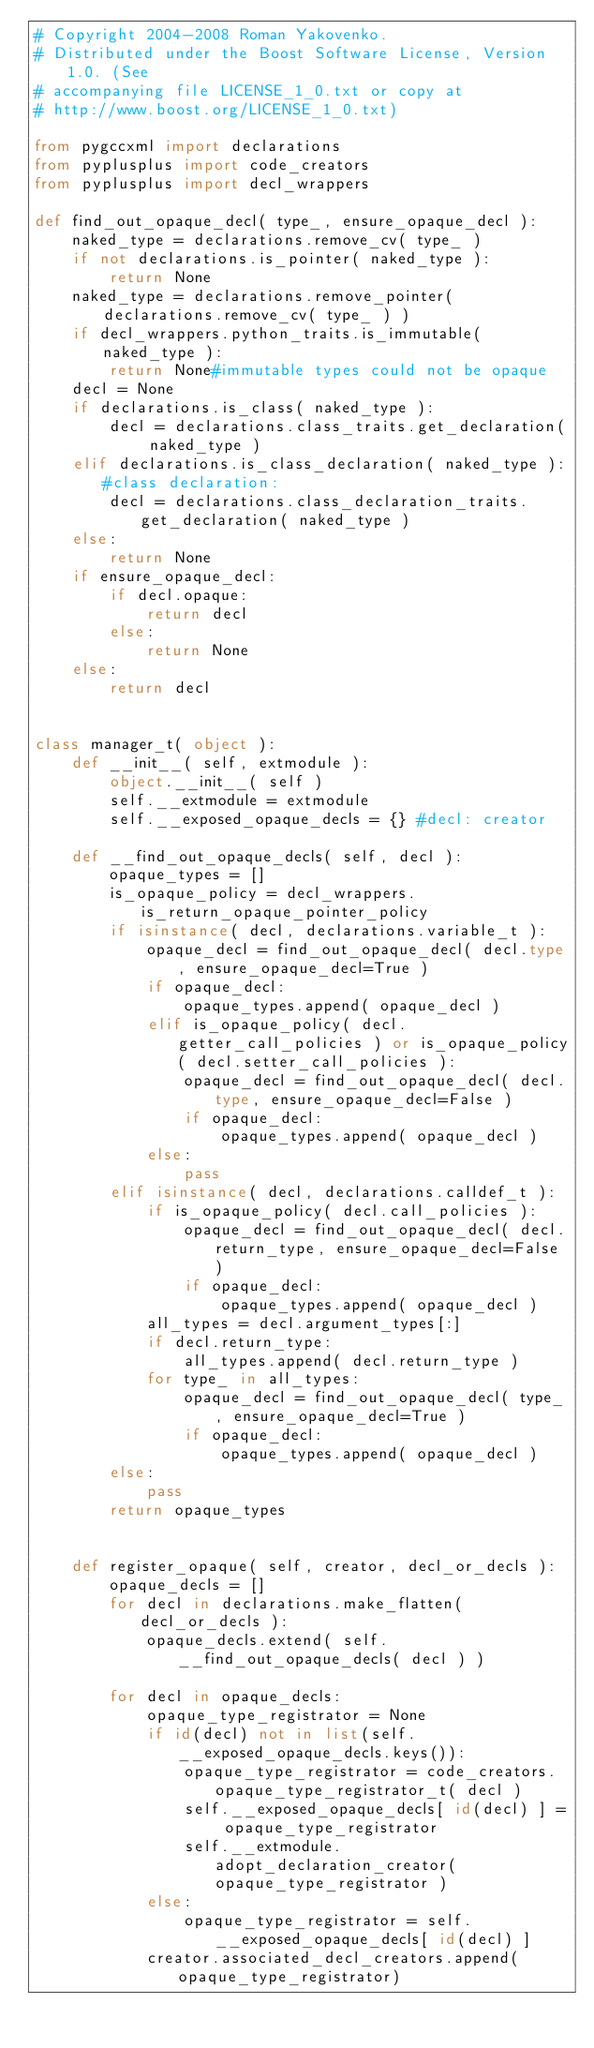Convert code to text. <code><loc_0><loc_0><loc_500><loc_500><_Python_># Copyright 2004-2008 Roman Yakovenko.
# Distributed under the Boost Software License, Version 1.0. (See
# accompanying file LICENSE_1_0.txt or copy at
# http://www.boost.org/LICENSE_1_0.txt)

from pygccxml import declarations
from pyplusplus import code_creators
from pyplusplus import decl_wrappers

def find_out_opaque_decl( type_, ensure_opaque_decl ):
    naked_type = declarations.remove_cv( type_ )
    if not declarations.is_pointer( naked_type ):
        return None
    naked_type = declarations.remove_pointer( declarations.remove_cv( type_ ) )
    if decl_wrappers.python_traits.is_immutable( naked_type ):
        return None#immutable types could not be opaque
    decl = None
    if declarations.is_class( naked_type ):
        decl = declarations.class_traits.get_declaration( naked_type )
    elif declarations.is_class_declaration( naked_type ):#class declaration:
        decl = declarations.class_declaration_traits.get_declaration( naked_type )
    else:
        return None
    if ensure_opaque_decl:
        if decl.opaque:
            return decl
        else:
            return None
    else:
        return decl


class manager_t( object ):
    def __init__( self, extmodule ):
        object.__init__( self )
        self.__extmodule = extmodule
        self.__exposed_opaque_decls = {} #decl: creator
        
    def __find_out_opaque_decls( self, decl ):
        opaque_types = []
        is_opaque_policy = decl_wrappers.is_return_opaque_pointer_policy
        if isinstance( decl, declarations.variable_t ):
            opaque_decl = find_out_opaque_decl( decl.type, ensure_opaque_decl=True )
            if opaque_decl:
                opaque_types.append( opaque_decl )
            elif is_opaque_policy( decl.getter_call_policies ) or is_opaque_policy( decl.setter_call_policies ):
                opaque_decl = find_out_opaque_decl( decl.type, ensure_opaque_decl=False )
                if opaque_decl:
                    opaque_types.append( opaque_decl )
            else:
                pass
        elif isinstance( decl, declarations.calldef_t ):
            if is_opaque_policy( decl.call_policies ):
                opaque_decl = find_out_opaque_decl( decl.return_type, ensure_opaque_decl=False )
                if opaque_decl:
                    opaque_types.append( opaque_decl )
            all_types = decl.argument_types[:]
            if decl.return_type:
                all_types.append( decl.return_type )    
            for type_ in all_types:
                opaque_decl = find_out_opaque_decl( type_, ensure_opaque_decl=True )
                if opaque_decl:
                    opaque_types.append( opaque_decl )
        else:
            pass
        return opaque_types
            
            
    def register_opaque( self, creator, decl_or_decls ):
        opaque_decls = []
        for decl in declarations.make_flatten( decl_or_decls ):
            opaque_decls.extend( self.__find_out_opaque_decls( decl ) )
            
        for decl in opaque_decls:
            opaque_type_registrator = None
            if id(decl) not in list(self.__exposed_opaque_decls.keys()):
                opaque_type_registrator = code_creators.opaque_type_registrator_t( decl )
                self.__exposed_opaque_decls[ id(decl) ] = opaque_type_registrator
                self.__extmodule.adopt_declaration_creator( opaque_type_registrator )
            else:
                opaque_type_registrator = self.__exposed_opaque_decls[ id(decl) ]
            creator.associated_decl_creators.append(opaque_type_registrator)
</code> 